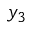<formula> <loc_0><loc_0><loc_500><loc_500>y _ { 3 }</formula> 